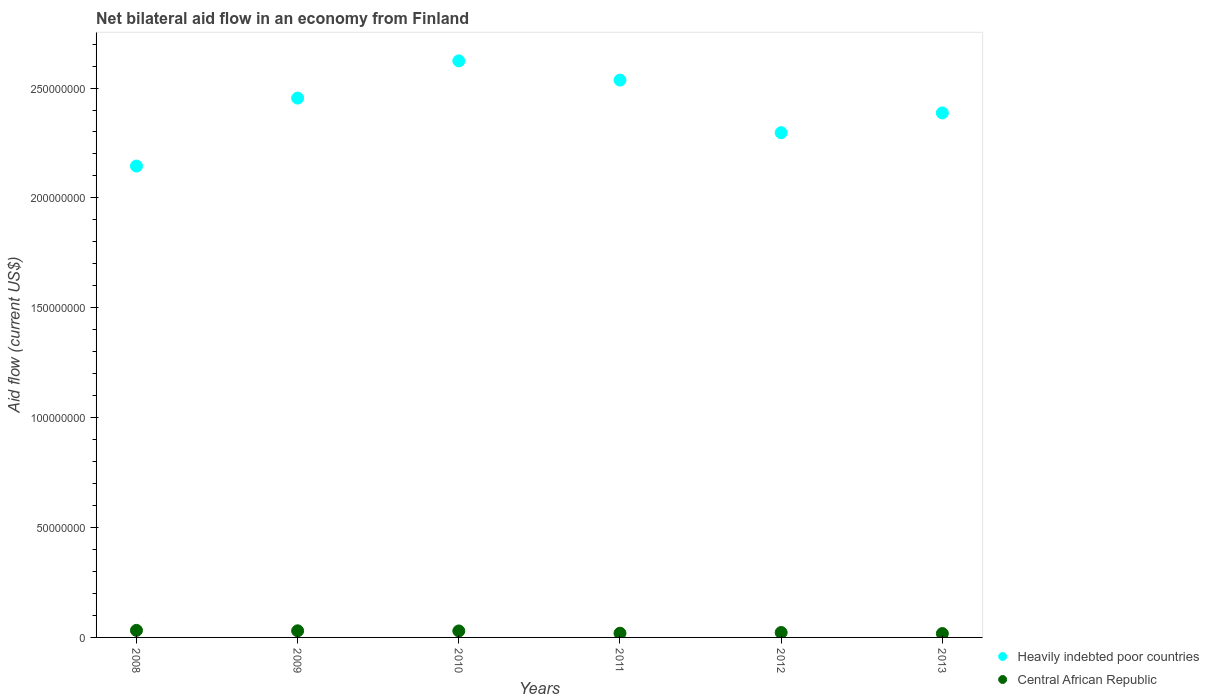How many different coloured dotlines are there?
Provide a short and direct response. 2. What is the net bilateral aid flow in Central African Republic in 2013?
Make the answer very short. 1.76e+06. Across all years, what is the maximum net bilateral aid flow in Heavily indebted poor countries?
Offer a very short reply. 2.62e+08. Across all years, what is the minimum net bilateral aid flow in Heavily indebted poor countries?
Your answer should be compact. 2.14e+08. In which year was the net bilateral aid flow in Central African Republic minimum?
Make the answer very short. 2013. What is the total net bilateral aid flow in Central African Republic in the graph?
Offer a very short reply. 1.50e+07. What is the difference between the net bilateral aid flow in Central African Republic in 2011 and that in 2012?
Give a very brief answer. -3.20e+05. What is the difference between the net bilateral aid flow in Central African Republic in 2010 and the net bilateral aid flow in Heavily indebted poor countries in 2012?
Ensure brevity in your answer.  -2.27e+08. What is the average net bilateral aid flow in Central African Republic per year?
Keep it short and to the point. 2.51e+06. In the year 2013, what is the difference between the net bilateral aid flow in Central African Republic and net bilateral aid flow in Heavily indebted poor countries?
Keep it short and to the point. -2.37e+08. In how many years, is the net bilateral aid flow in Central African Republic greater than 210000000 US$?
Provide a short and direct response. 0. What is the ratio of the net bilateral aid flow in Heavily indebted poor countries in 2008 to that in 2012?
Your answer should be very brief. 0.93. What is the difference between the highest and the lowest net bilateral aid flow in Central African Republic?
Give a very brief answer. 1.44e+06. Is the sum of the net bilateral aid flow in Central African Republic in 2010 and 2011 greater than the maximum net bilateral aid flow in Heavily indebted poor countries across all years?
Keep it short and to the point. No. Is the net bilateral aid flow in Central African Republic strictly greater than the net bilateral aid flow in Heavily indebted poor countries over the years?
Your answer should be compact. No. Is the net bilateral aid flow in Central African Republic strictly less than the net bilateral aid flow in Heavily indebted poor countries over the years?
Your response must be concise. Yes. What is the difference between two consecutive major ticks on the Y-axis?
Your answer should be very brief. 5.00e+07. Are the values on the major ticks of Y-axis written in scientific E-notation?
Keep it short and to the point. No. Does the graph contain any zero values?
Keep it short and to the point. No. Does the graph contain grids?
Your response must be concise. No. Where does the legend appear in the graph?
Your answer should be very brief. Bottom right. How are the legend labels stacked?
Your answer should be compact. Vertical. What is the title of the graph?
Your answer should be very brief. Net bilateral aid flow in an economy from Finland. Does "Malta" appear as one of the legend labels in the graph?
Your answer should be compact. No. What is the label or title of the X-axis?
Offer a very short reply. Years. What is the Aid flow (current US$) in Heavily indebted poor countries in 2008?
Provide a short and direct response. 2.14e+08. What is the Aid flow (current US$) of Central African Republic in 2008?
Ensure brevity in your answer.  3.20e+06. What is the Aid flow (current US$) in Heavily indebted poor countries in 2009?
Offer a terse response. 2.45e+08. What is the Aid flow (current US$) of Central African Republic in 2009?
Make the answer very short. 3.01e+06. What is the Aid flow (current US$) of Heavily indebted poor countries in 2010?
Your answer should be compact. 2.62e+08. What is the Aid flow (current US$) of Central African Republic in 2010?
Give a very brief answer. 2.94e+06. What is the Aid flow (current US$) of Heavily indebted poor countries in 2011?
Your answer should be very brief. 2.54e+08. What is the Aid flow (current US$) of Central African Republic in 2011?
Your response must be concise. 1.91e+06. What is the Aid flow (current US$) in Heavily indebted poor countries in 2012?
Keep it short and to the point. 2.30e+08. What is the Aid flow (current US$) of Central African Republic in 2012?
Provide a short and direct response. 2.23e+06. What is the Aid flow (current US$) in Heavily indebted poor countries in 2013?
Offer a very short reply. 2.39e+08. What is the Aid flow (current US$) in Central African Republic in 2013?
Your answer should be very brief. 1.76e+06. Across all years, what is the maximum Aid flow (current US$) in Heavily indebted poor countries?
Keep it short and to the point. 2.62e+08. Across all years, what is the maximum Aid flow (current US$) in Central African Republic?
Provide a succinct answer. 3.20e+06. Across all years, what is the minimum Aid flow (current US$) in Heavily indebted poor countries?
Give a very brief answer. 2.14e+08. Across all years, what is the minimum Aid flow (current US$) of Central African Republic?
Your answer should be very brief. 1.76e+06. What is the total Aid flow (current US$) of Heavily indebted poor countries in the graph?
Offer a very short reply. 1.44e+09. What is the total Aid flow (current US$) of Central African Republic in the graph?
Provide a short and direct response. 1.50e+07. What is the difference between the Aid flow (current US$) in Heavily indebted poor countries in 2008 and that in 2009?
Keep it short and to the point. -3.09e+07. What is the difference between the Aid flow (current US$) of Heavily indebted poor countries in 2008 and that in 2010?
Keep it short and to the point. -4.79e+07. What is the difference between the Aid flow (current US$) of Heavily indebted poor countries in 2008 and that in 2011?
Your response must be concise. -3.91e+07. What is the difference between the Aid flow (current US$) in Central African Republic in 2008 and that in 2011?
Your response must be concise. 1.29e+06. What is the difference between the Aid flow (current US$) in Heavily indebted poor countries in 2008 and that in 2012?
Ensure brevity in your answer.  -1.52e+07. What is the difference between the Aid flow (current US$) in Central African Republic in 2008 and that in 2012?
Your answer should be compact. 9.70e+05. What is the difference between the Aid flow (current US$) of Heavily indebted poor countries in 2008 and that in 2013?
Keep it short and to the point. -2.42e+07. What is the difference between the Aid flow (current US$) in Central African Republic in 2008 and that in 2013?
Give a very brief answer. 1.44e+06. What is the difference between the Aid flow (current US$) in Heavily indebted poor countries in 2009 and that in 2010?
Give a very brief answer. -1.69e+07. What is the difference between the Aid flow (current US$) of Central African Republic in 2009 and that in 2010?
Keep it short and to the point. 7.00e+04. What is the difference between the Aid flow (current US$) of Heavily indebted poor countries in 2009 and that in 2011?
Keep it short and to the point. -8.19e+06. What is the difference between the Aid flow (current US$) in Central African Republic in 2009 and that in 2011?
Give a very brief answer. 1.10e+06. What is the difference between the Aid flow (current US$) of Heavily indebted poor countries in 2009 and that in 2012?
Provide a succinct answer. 1.57e+07. What is the difference between the Aid flow (current US$) of Central African Republic in 2009 and that in 2012?
Ensure brevity in your answer.  7.80e+05. What is the difference between the Aid flow (current US$) in Heavily indebted poor countries in 2009 and that in 2013?
Make the answer very short. 6.75e+06. What is the difference between the Aid flow (current US$) of Central African Republic in 2009 and that in 2013?
Your answer should be compact. 1.25e+06. What is the difference between the Aid flow (current US$) in Heavily indebted poor countries in 2010 and that in 2011?
Make the answer very short. 8.74e+06. What is the difference between the Aid flow (current US$) in Central African Republic in 2010 and that in 2011?
Provide a short and direct response. 1.03e+06. What is the difference between the Aid flow (current US$) of Heavily indebted poor countries in 2010 and that in 2012?
Give a very brief answer. 3.27e+07. What is the difference between the Aid flow (current US$) in Central African Republic in 2010 and that in 2012?
Keep it short and to the point. 7.10e+05. What is the difference between the Aid flow (current US$) of Heavily indebted poor countries in 2010 and that in 2013?
Give a very brief answer. 2.37e+07. What is the difference between the Aid flow (current US$) of Central African Republic in 2010 and that in 2013?
Give a very brief answer. 1.18e+06. What is the difference between the Aid flow (current US$) of Heavily indebted poor countries in 2011 and that in 2012?
Ensure brevity in your answer.  2.39e+07. What is the difference between the Aid flow (current US$) in Central African Republic in 2011 and that in 2012?
Your response must be concise. -3.20e+05. What is the difference between the Aid flow (current US$) in Heavily indebted poor countries in 2011 and that in 2013?
Your response must be concise. 1.49e+07. What is the difference between the Aid flow (current US$) in Heavily indebted poor countries in 2012 and that in 2013?
Offer a very short reply. -8.98e+06. What is the difference between the Aid flow (current US$) of Heavily indebted poor countries in 2008 and the Aid flow (current US$) of Central African Republic in 2009?
Offer a very short reply. 2.11e+08. What is the difference between the Aid flow (current US$) of Heavily indebted poor countries in 2008 and the Aid flow (current US$) of Central African Republic in 2010?
Keep it short and to the point. 2.12e+08. What is the difference between the Aid flow (current US$) in Heavily indebted poor countries in 2008 and the Aid flow (current US$) in Central African Republic in 2011?
Offer a terse response. 2.13e+08. What is the difference between the Aid flow (current US$) of Heavily indebted poor countries in 2008 and the Aid flow (current US$) of Central African Republic in 2012?
Keep it short and to the point. 2.12e+08. What is the difference between the Aid flow (current US$) of Heavily indebted poor countries in 2008 and the Aid flow (current US$) of Central African Republic in 2013?
Make the answer very short. 2.13e+08. What is the difference between the Aid flow (current US$) in Heavily indebted poor countries in 2009 and the Aid flow (current US$) in Central African Republic in 2010?
Your response must be concise. 2.42e+08. What is the difference between the Aid flow (current US$) in Heavily indebted poor countries in 2009 and the Aid flow (current US$) in Central African Republic in 2011?
Ensure brevity in your answer.  2.44e+08. What is the difference between the Aid flow (current US$) of Heavily indebted poor countries in 2009 and the Aid flow (current US$) of Central African Republic in 2012?
Provide a succinct answer. 2.43e+08. What is the difference between the Aid flow (current US$) of Heavily indebted poor countries in 2009 and the Aid flow (current US$) of Central African Republic in 2013?
Your answer should be compact. 2.44e+08. What is the difference between the Aid flow (current US$) of Heavily indebted poor countries in 2010 and the Aid flow (current US$) of Central African Republic in 2011?
Your answer should be very brief. 2.60e+08. What is the difference between the Aid flow (current US$) in Heavily indebted poor countries in 2010 and the Aid flow (current US$) in Central African Republic in 2012?
Offer a very short reply. 2.60e+08. What is the difference between the Aid flow (current US$) of Heavily indebted poor countries in 2010 and the Aid flow (current US$) of Central African Republic in 2013?
Your response must be concise. 2.61e+08. What is the difference between the Aid flow (current US$) in Heavily indebted poor countries in 2011 and the Aid flow (current US$) in Central African Republic in 2012?
Offer a very short reply. 2.51e+08. What is the difference between the Aid flow (current US$) in Heavily indebted poor countries in 2011 and the Aid flow (current US$) in Central African Republic in 2013?
Provide a succinct answer. 2.52e+08. What is the difference between the Aid flow (current US$) in Heavily indebted poor countries in 2012 and the Aid flow (current US$) in Central African Republic in 2013?
Offer a terse response. 2.28e+08. What is the average Aid flow (current US$) of Heavily indebted poor countries per year?
Offer a terse response. 2.41e+08. What is the average Aid flow (current US$) in Central African Republic per year?
Give a very brief answer. 2.51e+06. In the year 2008, what is the difference between the Aid flow (current US$) in Heavily indebted poor countries and Aid flow (current US$) in Central African Republic?
Your answer should be very brief. 2.11e+08. In the year 2009, what is the difference between the Aid flow (current US$) of Heavily indebted poor countries and Aid flow (current US$) of Central African Republic?
Provide a short and direct response. 2.42e+08. In the year 2010, what is the difference between the Aid flow (current US$) of Heavily indebted poor countries and Aid flow (current US$) of Central African Republic?
Your response must be concise. 2.59e+08. In the year 2011, what is the difference between the Aid flow (current US$) in Heavily indebted poor countries and Aid flow (current US$) in Central African Republic?
Ensure brevity in your answer.  2.52e+08. In the year 2012, what is the difference between the Aid flow (current US$) in Heavily indebted poor countries and Aid flow (current US$) in Central African Republic?
Give a very brief answer. 2.27e+08. In the year 2013, what is the difference between the Aid flow (current US$) in Heavily indebted poor countries and Aid flow (current US$) in Central African Republic?
Keep it short and to the point. 2.37e+08. What is the ratio of the Aid flow (current US$) of Heavily indebted poor countries in 2008 to that in 2009?
Offer a terse response. 0.87. What is the ratio of the Aid flow (current US$) in Central African Republic in 2008 to that in 2009?
Provide a short and direct response. 1.06. What is the ratio of the Aid flow (current US$) of Heavily indebted poor countries in 2008 to that in 2010?
Ensure brevity in your answer.  0.82. What is the ratio of the Aid flow (current US$) in Central African Republic in 2008 to that in 2010?
Provide a short and direct response. 1.09. What is the ratio of the Aid flow (current US$) of Heavily indebted poor countries in 2008 to that in 2011?
Your response must be concise. 0.85. What is the ratio of the Aid flow (current US$) of Central African Republic in 2008 to that in 2011?
Offer a very short reply. 1.68. What is the ratio of the Aid flow (current US$) of Heavily indebted poor countries in 2008 to that in 2012?
Offer a very short reply. 0.93. What is the ratio of the Aid flow (current US$) of Central African Republic in 2008 to that in 2012?
Ensure brevity in your answer.  1.44. What is the ratio of the Aid flow (current US$) in Heavily indebted poor countries in 2008 to that in 2013?
Make the answer very short. 0.9. What is the ratio of the Aid flow (current US$) of Central African Republic in 2008 to that in 2013?
Your answer should be compact. 1.82. What is the ratio of the Aid flow (current US$) in Heavily indebted poor countries in 2009 to that in 2010?
Offer a very short reply. 0.94. What is the ratio of the Aid flow (current US$) of Central African Republic in 2009 to that in 2010?
Keep it short and to the point. 1.02. What is the ratio of the Aid flow (current US$) of Central African Republic in 2009 to that in 2011?
Provide a succinct answer. 1.58. What is the ratio of the Aid flow (current US$) in Heavily indebted poor countries in 2009 to that in 2012?
Your answer should be very brief. 1.07. What is the ratio of the Aid flow (current US$) of Central African Republic in 2009 to that in 2012?
Keep it short and to the point. 1.35. What is the ratio of the Aid flow (current US$) of Heavily indebted poor countries in 2009 to that in 2013?
Offer a terse response. 1.03. What is the ratio of the Aid flow (current US$) of Central African Republic in 2009 to that in 2013?
Offer a terse response. 1.71. What is the ratio of the Aid flow (current US$) in Heavily indebted poor countries in 2010 to that in 2011?
Keep it short and to the point. 1.03. What is the ratio of the Aid flow (current US$) of Central African Republic in 2010 to that in 2011?
Your answer should be very brief. 1.54. What is the ratio of the Aid flow (current US$) in Heavily indebted poor countries in 2010 to that in 2012?
Offer a very short reply. 1.14. What is the ratio of the Aid flow (current US$) in Central African Republic in 2010 to that in 2012?
Provide a succinct answer. 1.32. What is the ratio of the Aid flow (current US$) of Heavily indebted poor countries in 2010 to that in 2013?
Offer a very short reply. 1.1. What is the ratio of the Aid flow (current US$) of Central African Republic in 2010 to that in 2013?
Offer a terse response. 1.67. What is the ratio of the Aid flow (current US$) in Heavily indebted poor countries in 2011 to that in 2012?
Your answer should be very brief. 1.1. What is the ratio of the Aid flow (current US$) in Central African Republic in 2011 to that in 2012?
Your response must be concise. 0.86. What is the ratio of the Aid flow (current US$) of Heavily indebted poor countries in 2011 to that in 2013?
Make the answer very short. 1.06. What is the ratio of the Aid flow (current US$) of Central African Republic in 2011 to that in 2013?
Give a very brief answer. 1.09. What is the ratio of the Aid flow (current US$) of Heavily indebted poor countries in 2012 to that in 2013?
Your answer should be very brief. 0.96. What is the ratio of the Aid flow (current US$) in Central African Republic in 2012 to that in 2013?
Offer a very short reply. 1.27. What is the difference between the highest and the second highest Aid flow (current US$) of Heavily indebted poor countries?
Provide a succinct answer. 8.74e+06. What is the difference between the highest and the second highest Aid flow (current US$) of Central African Republic?
Your answer should be very brief. 1.90e+05. What is the difference between the highest and the lowest Aid flow (current US$) in Heavily indebted poor countries?
Offer a very short reply. 4.79e+07. What is the difference between the highest and the lowest Aid flow (current US$) in Central African Republic?
Your answer should be very brief. 1.44e+06. 